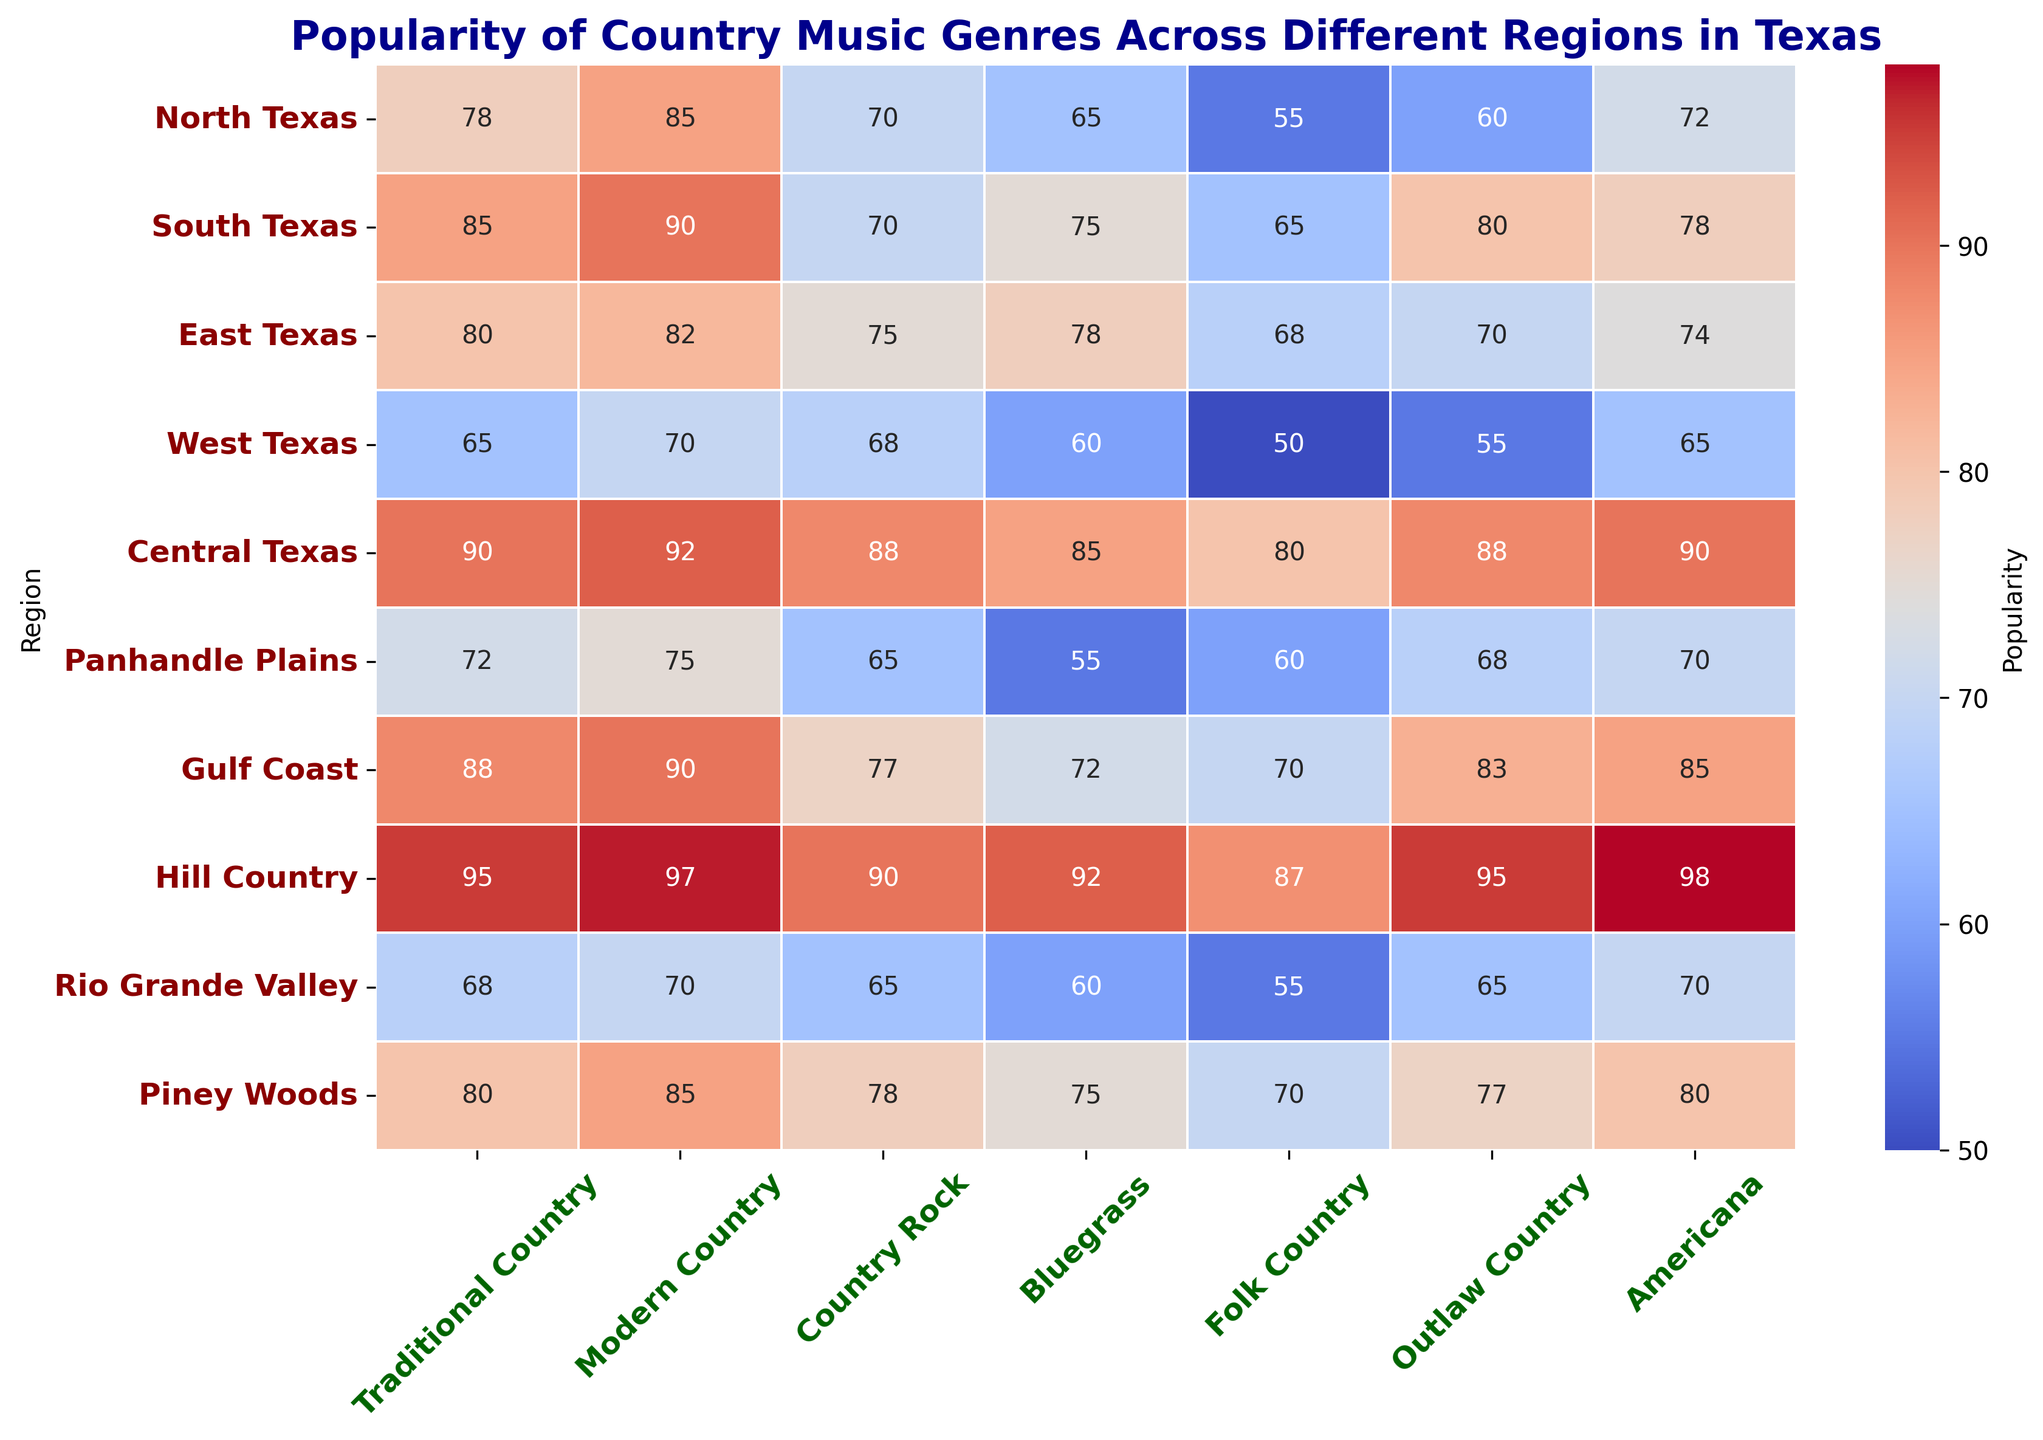Which region has the highest popularity for Traditional Country? The cell with the highest value in the Traditional Country column is the darkest blue color. This value is 95, which is in the Hill Country region row.
Answer: Hill Country Which genre is the least popular in West Texas? In the row for West Texas, the smallest value is under the Folk Country column, which is 50.
Answer: Folk Country What are the two most popular genres in Central Texas? To find the two highest values in the Central Texas row, we look at each column value: Traditional Country (90), Modern Country (92), Country Rock (88), Bluegrass (85), Folk Country (80), Outlaw Country (88), and Americana (90). The highest values are 92 (Modern Country) and 90 (Americana and Traditional Country).
Answer: Modern Country, Americana, Traditional Country (all with 90) How does bluegrass popularity in East Texas compare to Gulf Coast? The value for Bluegrass in East Texas is 78, while in Gulf Coast, it is 72. Comparing these numbers, 78 is greater than 72.
Answer: East Texas has higher Bluegrass popularity than Gulf Coast What’s the average popularity of Americana across all regions? Sum the values of Americana across all regions and divide by the number of regions. The values are: 72, 78, 74, 65, 90, 70, 85, 98, 70, 80. The sum is 782. The average is 782/10 = 78.2.
Answer: 78.2 Which regions have more than 80 in Modern Country popularity? We look through the Modern Country column for values greater than 80. The regions satisfying this are North Texas (85), South Texas (90), East Texas (82), Central Texas (92), Gulf Coast (90), Hill Country (97), and Piney Woods (85).
Answer: North Texas, South Texas, East Texas, Central Texas, Gulf Coast, Hill Country, Piney Woods What is the difference in popularity of Outlaw Country between North Texas and South Texas? The value for Outlaw Country in North Texas is 60, and in South Texas, it is 80. The difference is 80 - 60 = 20.
Answer: 20 What is the total popularity of all genres in Piney Woods? Sum all the values in the Piney Woods row: Traditional Country (80), Modern Country (85), Country Rock (78), Bluegrass (75), Folk Country (70), Outlaw Country (77), and Americana (80). The total is 80 + 85 + 78 + 75 + 70 + 77 + 80 = 545.
Answer: 545 In which region are Folk Country and Americana equally popular? Identify the regions where the values for Folk Country and Americana are the same. This occurs in the Rio Grande Valley where both Folk Country and Americana have the value 70.
Answer: Rio Grande Valley In which region is Traditional Country significantly more popular compared to other genres? Look for the region where the value for Traditional Country is much higher compared to other genres in the same row. In Hill Country, Traditional Country is at 95, which is significantly higher compared to other values in the same row.
Answer: Hill Country 